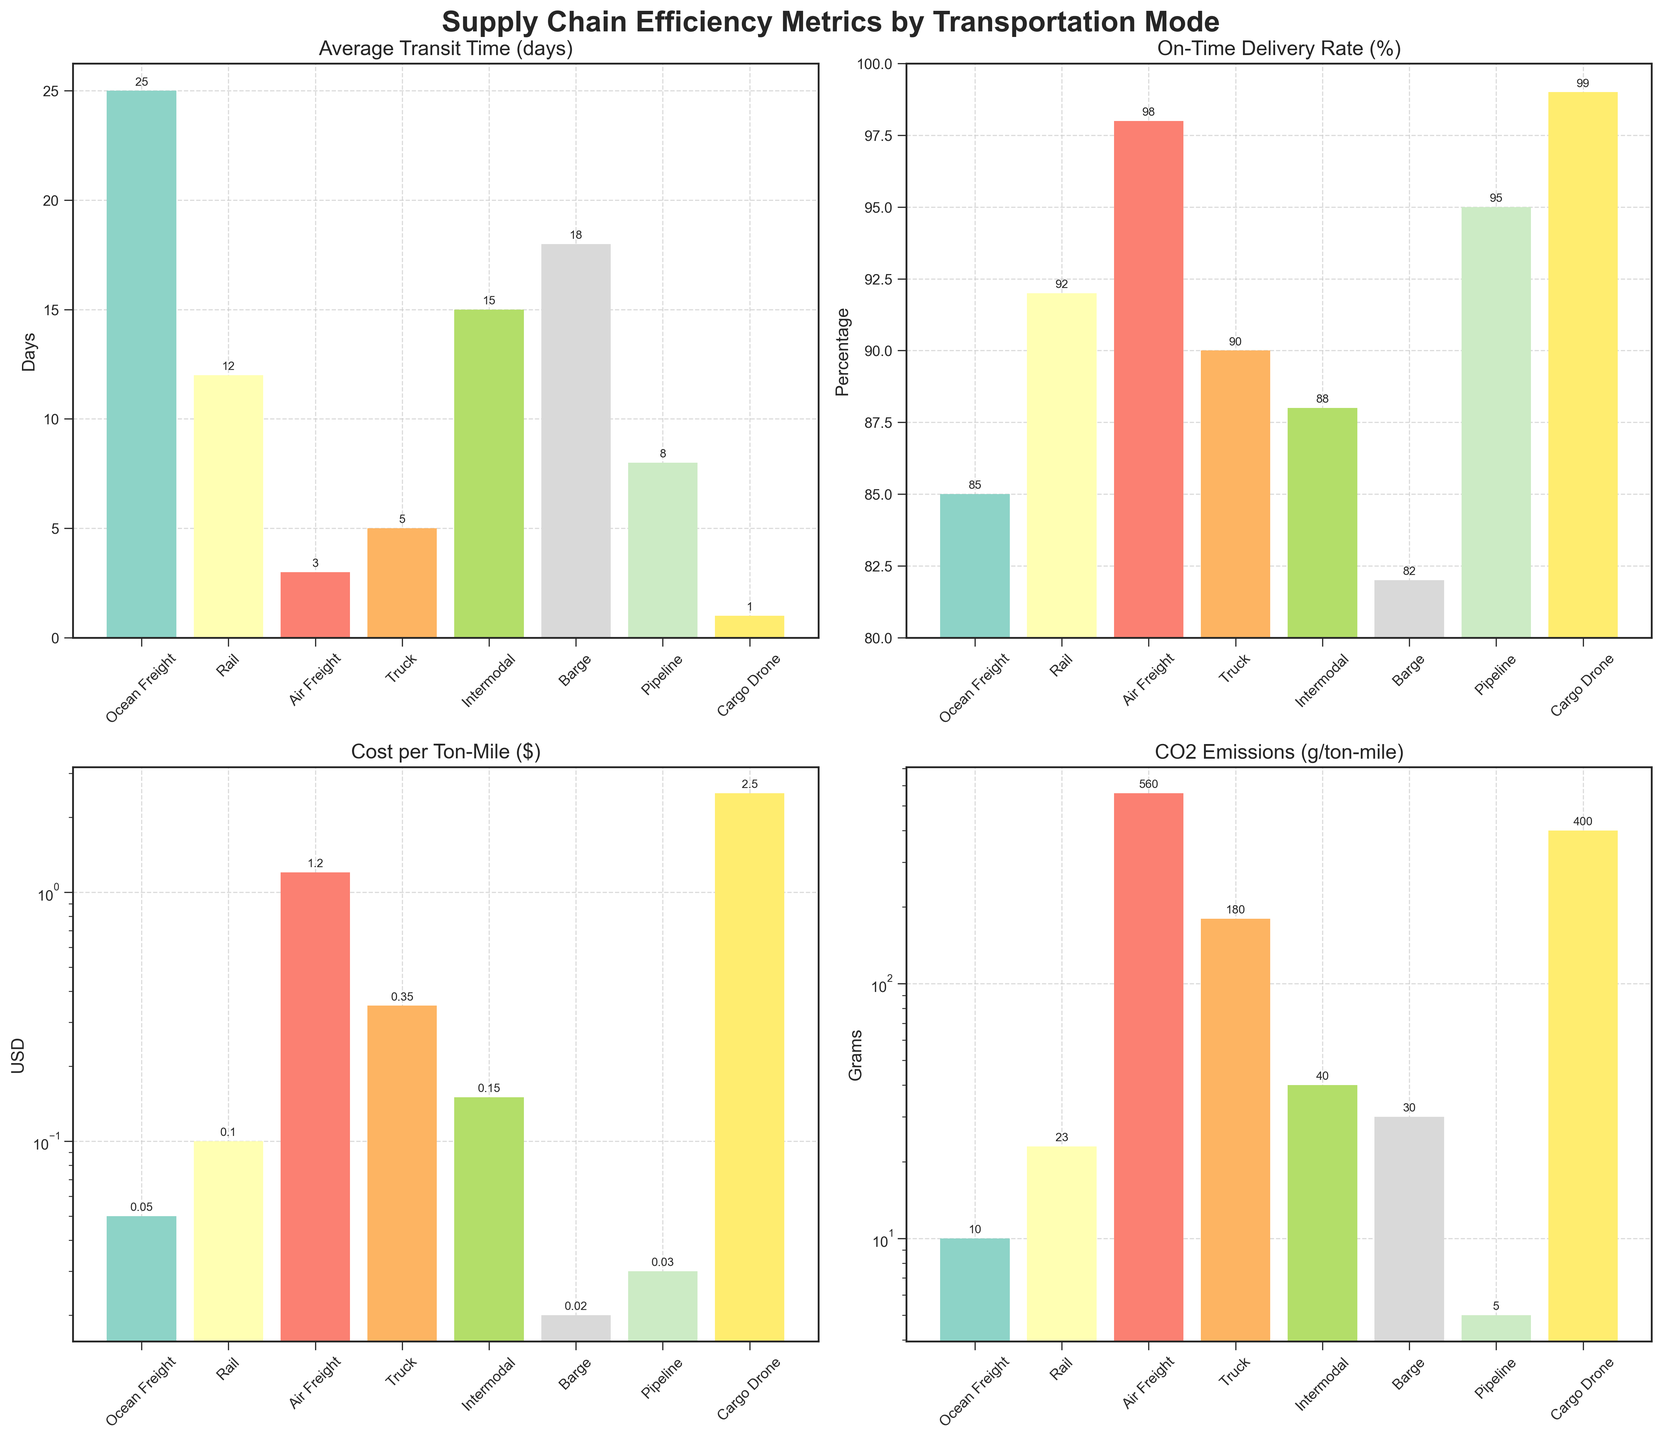Which transportation mode has the shortest average transit time? The transportation mode with the shortest average transit time can be determined by looking at the "Average Transit Time (days)" bar chart and identifying the bar with the smallest height. Cargo Drone has the shortest average transit time of 1 day.
Answer: Cargo Drone Which transportation mode emits the most CO2 per ton-mile? By examining the "CO2 Emissions (g/ton-mile)" chart, we can find the mode with the tallest bar, indicating the highest CO2 emissions. Air Freight has the highest CO2 emissions per ton-mile at 560 grams.
Answer: Air Freight What is the total cost per ton-mile for Rail and Truck combined? To find the total cost per ton-mile for Rail and Truck, locate their bars in the "Cost per Ton-Mile ($)" chart, and then add their respective values, which are $0.10 for Rail and $0.35 for Truck. The sum is $0.10 + $0.35 = $0.45.
Answer: $0.45 How does the on-time delivery rate of Pipeline compare to Truck? The on-time delivery rate can be compared by looking at their respective bars in the "On-Time Delivery Rate (%)" chart. Pipeline has a slightly higher on-time delivery rate of 95% compared to Truck's 90%.
Answer: Pipeline is higher Which transportation modes have CO2 emissions below 50 g/ton-mile? From the "CO2 Emissions (g/ton-mile)" chart, identify the bars representing emissions below 50 grams per ton-mile. Ocean Freight (10), Rail (23), Intermodal (40), and Pipeline (5) are the modes with emissions below 50 grams per ton-mile.
Answer: Ocean Freight, Rail, Intermodal, Pipeline Which transportation mode has the highest cost per ton-mile, and by how much does it exceed the mode with the second highest cost? First, identify the highest bar in the "Cost per Ton-Mile ($)" chart. Cargo Drone has the highest cost per ton-mile at $2.50. The second highest is Air Freight at $1.20. The difference is $2.50 - $1.20 = $1.30.
Answer: Cargo Drone, $1.30 What is the average on-time delivery rate for all transportation modes? Sum the on-time delivery rates for all modes: (85 + 92 + 98 + 90 + 88 + 82 + 95 + 99) = 729. Then, divide by the number of modes (8). 729 / 8 = 91.125.
Answer: 91.125% Which transportation mode has the second shortest average transit time and what is it? To determine the second shortest average transit time, rank the transit times in ascending order. Cargo Drone is the shortest with 1 day, followed by Air Freight with 3 days.
Answer: Air Freight, 3 days How much more does it cost per ton-mile to use Truck compared to Barge? Find the bars for Truck and Barge in the "Cost per Ton-Mile ($)" chart. Truck costs $0.35 per ton-mile, and Barge costs $0.02. The difference is $0.35 - $0.02 = $0.33.
Answer: $0.33 